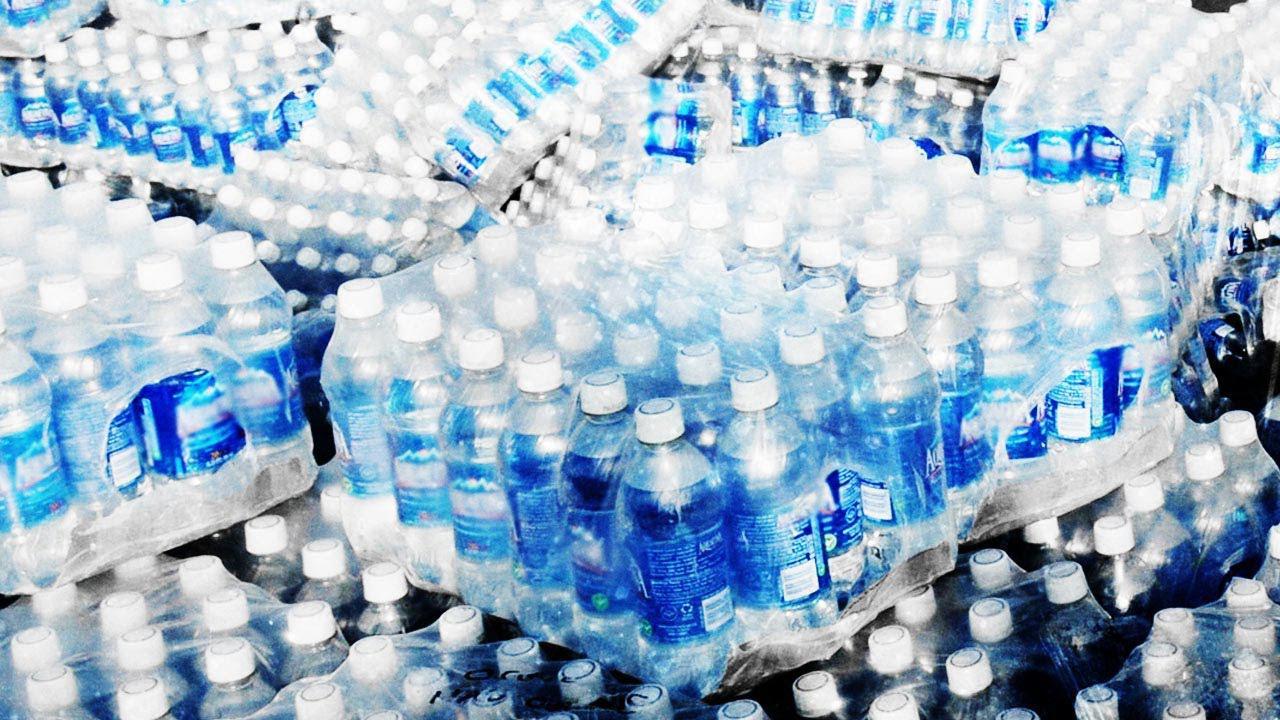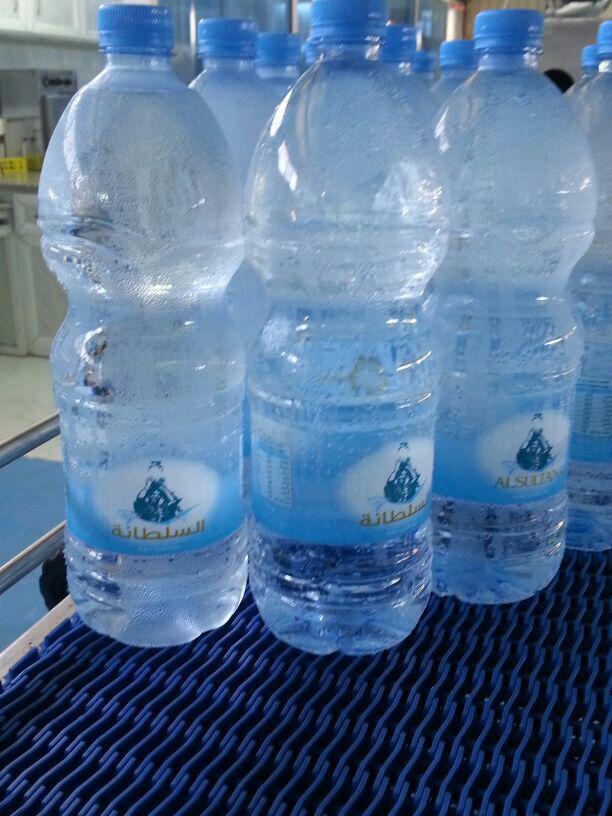The first image is the image on the left, the second image is the image on the right. For the images displayed, is the sentence "Bottles with blue caps are on a blue grated surface." factually correct? Answer yes or no. Yes. The first image is the image on the left, the second image is the image on the right. For the images shown, is this caption "an image shows individual, unwrapped bottles with white lids." true? Answer yes or no. No. 